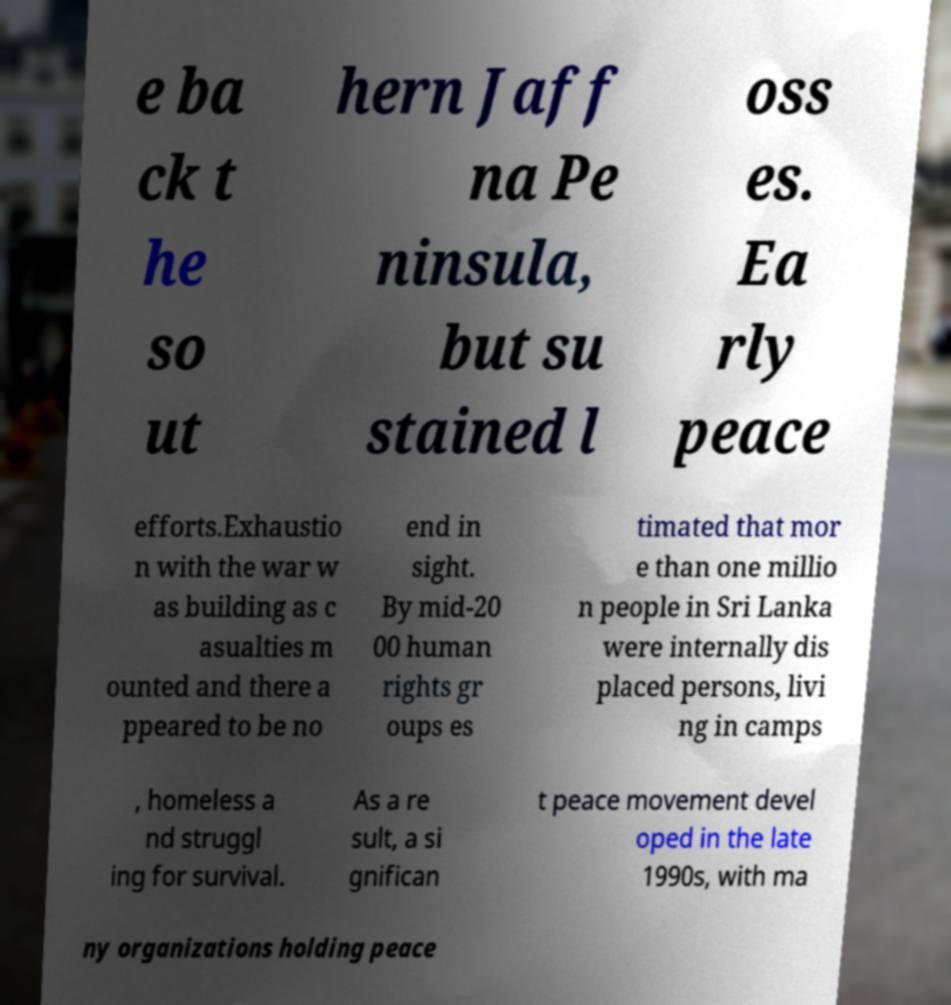I need the written content from this picture converted into text. Can you do that? e ba ck t he so ut hern Jaff na Pe ninsula, but su stained l oss es. Ea rly peace efforts.Exhaustio n with the war w as building as c asualties m ounted and there a ppeared to be no end in sight. By mid-20 00 human rights gr oups es timated that mor e than one millio n people in Sri Lanka were internally dis placed persons, livi ng in camps , homeless a nd struggl ing for survival. As a re sult, a si gnifican t peace movement devel oped in the late 1990s, with ma ny organizations holding peace 